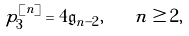<formula> <loc_0><loc_0><loc_500><loc_500>\ p _ { 3 } ^ { [ n ] } = 4 \mathfrak g _ { n - 2 } , \quad n \geq 2 ,</formula> 